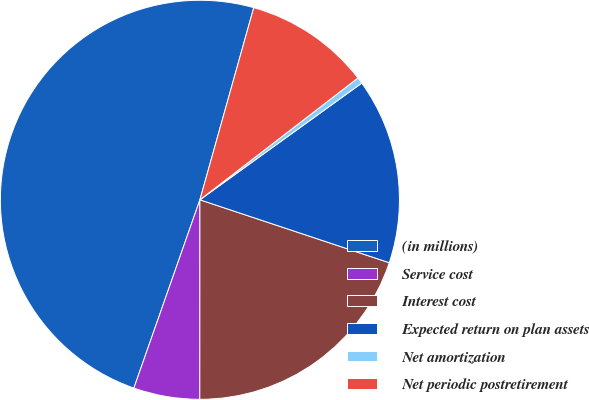<chart> <loc_0><loc_0><loc_500><loc_500><pie_chart><fcel>(in millions)<fcel>Service cost<fcel>Interest cost<fcel>Expected return on plan assets<fcel>Net amortization<fcel>Net periodic postretirement<nl><fcel>48.98%<fcel>5.36%<fcel>19.9%<fcel>15.05%<fcel>0.51%<fcel>10.2%<nl></chart> 